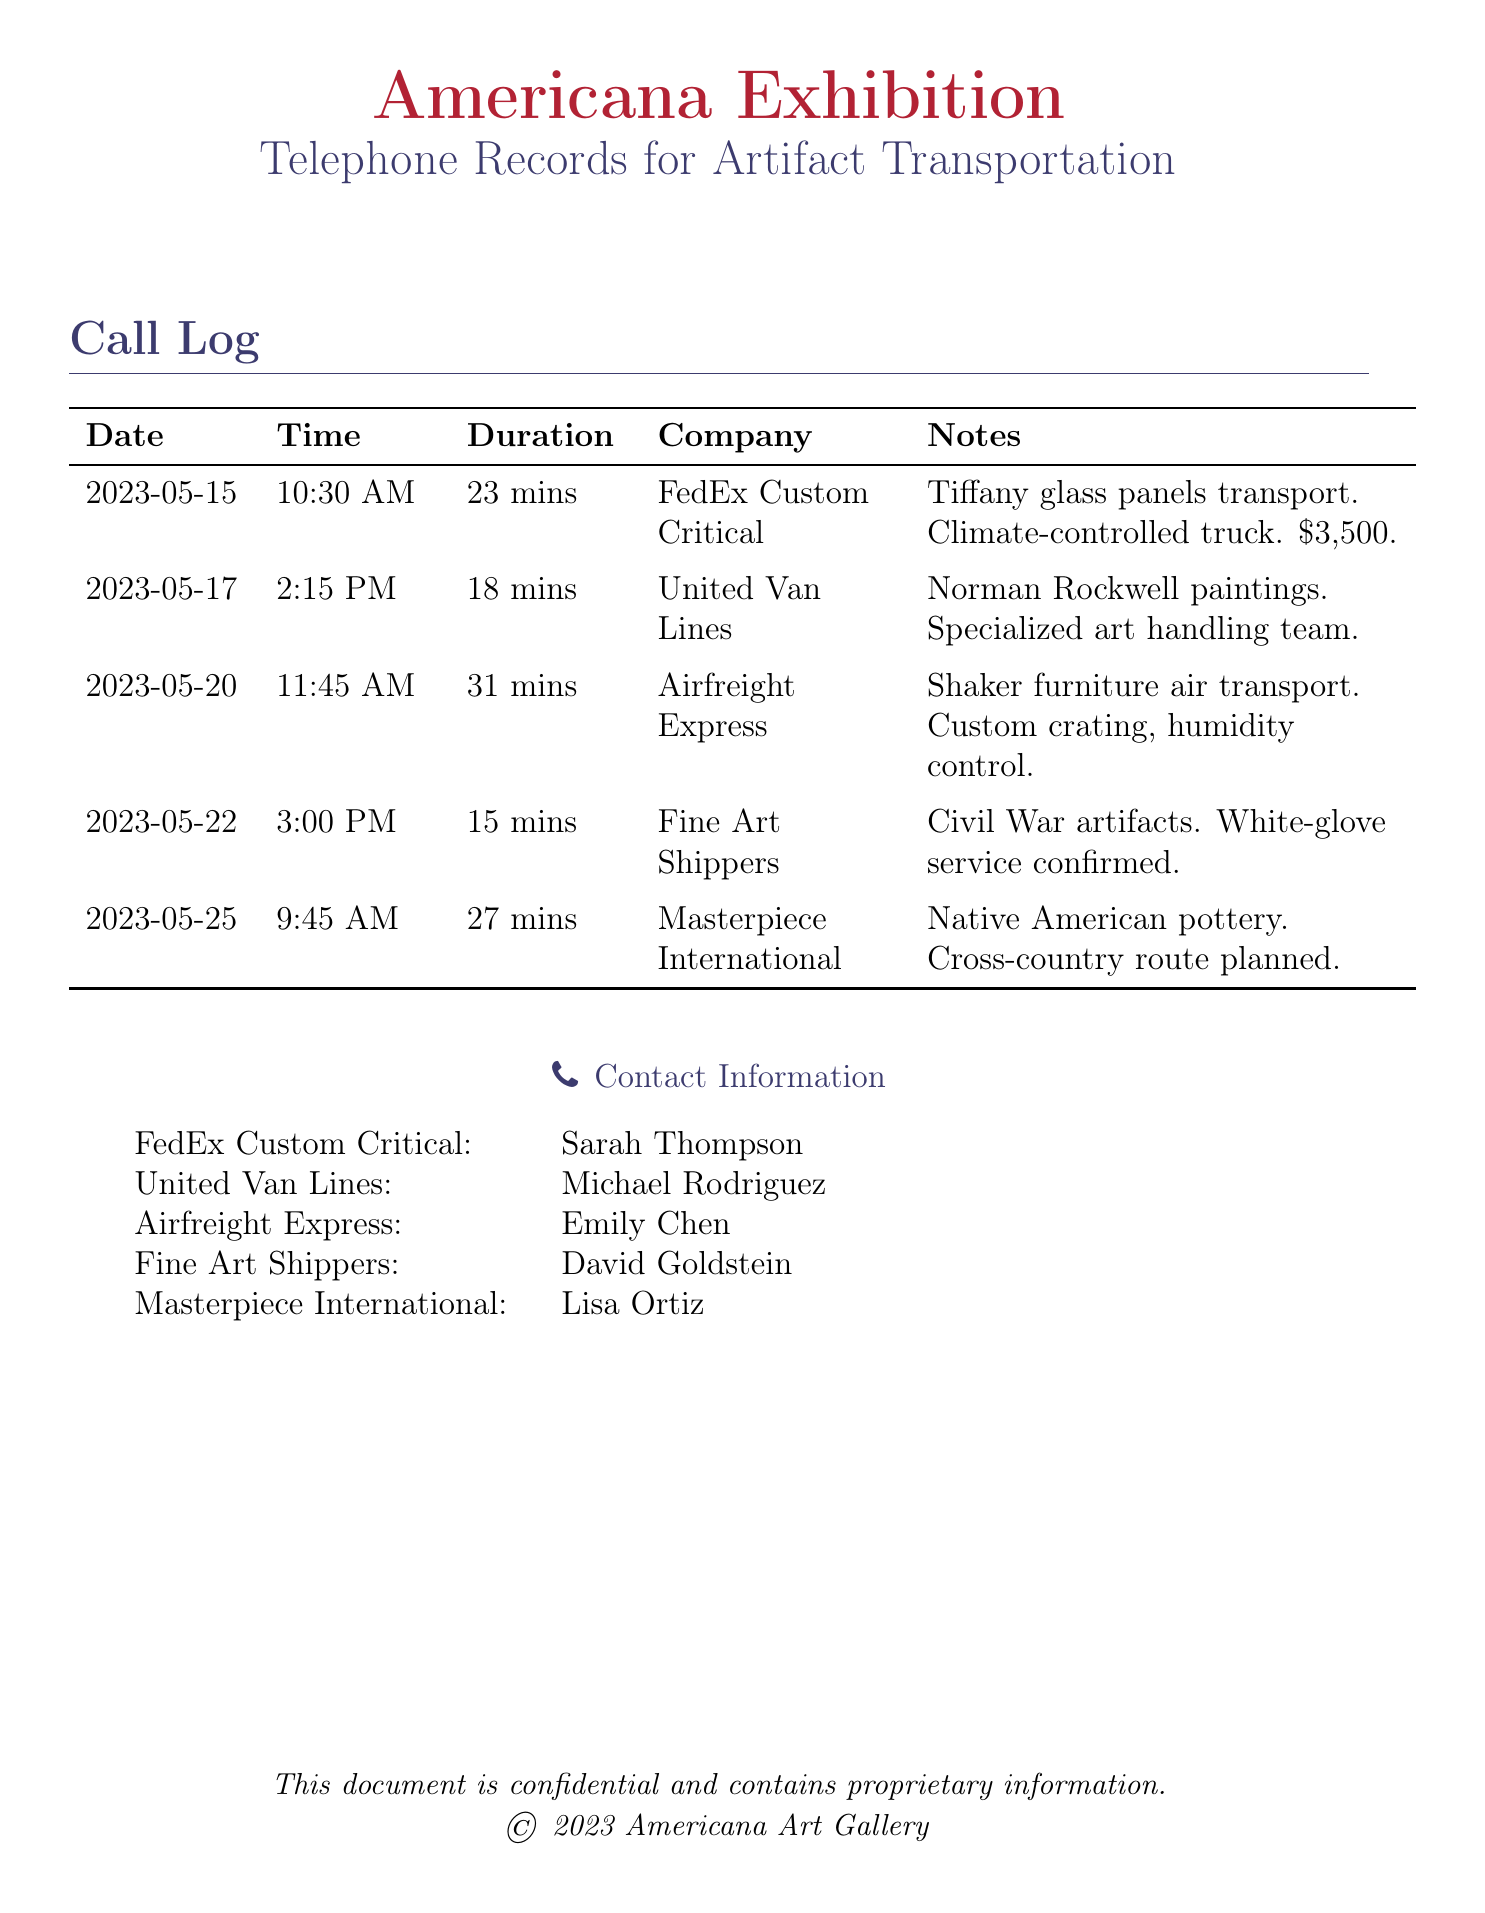What is the date of the call with FedEx Custom Critical? The call with FedEx Custom Critical took place on May 15, 2023.
Answer: May 15, 2023 How long was the call with United Van Lines? The duration of the call with United Van Lines was 18 minutes.
Answer: 18 mins What type of service was confirmed for the Civil War artifacts? The Fine Art Shippers provided white-glove service for the Civil War artifacts.
Answer: White-glove service Who is the contact person for Airfreight Express? The contact person for Airfreight Express is Emily Chen.
Answer: Emily Chen What was the cost for transporting Tiffany glass panels? The transportation cost for Tiffany glass panels was $3,500.
Answer: $3,500 Which company is responsible for transporting Native American pottery? Masterpiece International is responsible for transporting Native American pottery.
Answer: Masterpiece International What special handling was mentioned for the Shaker furniture? Custom crating and humidity control were mentioned for the Shaker furniture.
Answer: Custom crating, humidity control How many minutes did the call with Fine Art Shippers last? The call with Fine Art Shippers lasted 15 minutes.
Answer: 15 mins What type of artifacts were mentioned in the call on May 20? The artifacts mentioned on May 20 were Shaker furniture.
Answer: Shaker furniture 